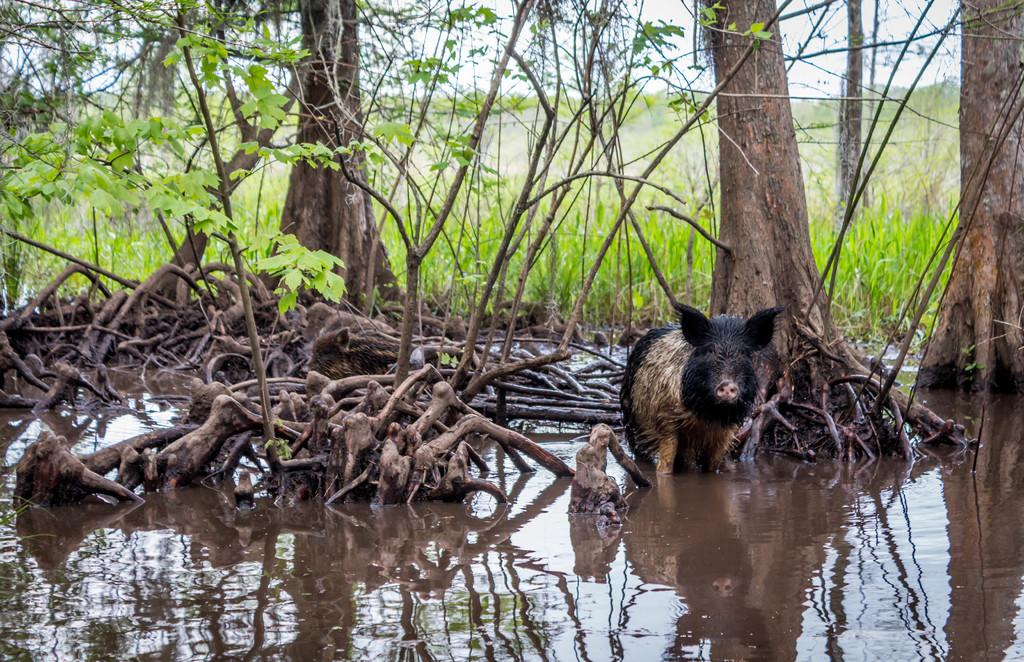What animal is present in the image? There is a pig in the image. What is the pig's environment like? The pig is in mud water. What can be seen behind the pig? There are trees behind the pig. What type of vegetation is visible in the background? There is grass visible in the background. What might be the location of the water the pig is in? The water might be in a pond. What is the condition of the table in the image? There is no table present in the image. What class of animal is the pig in the image? The pig is a mammal, but there is no need to classify the pig further in the context of the image. 